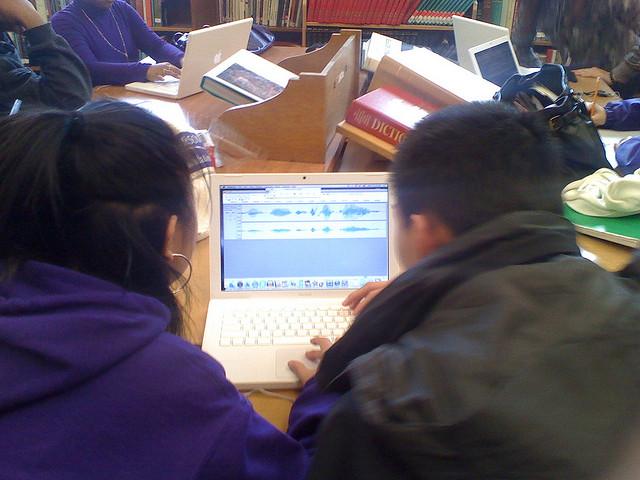How many computers?
Be succinct. 4. What color is their hair?
Concise answer only. Black. How many dictionaries are in the photo?
Write a very short answer. 1. 